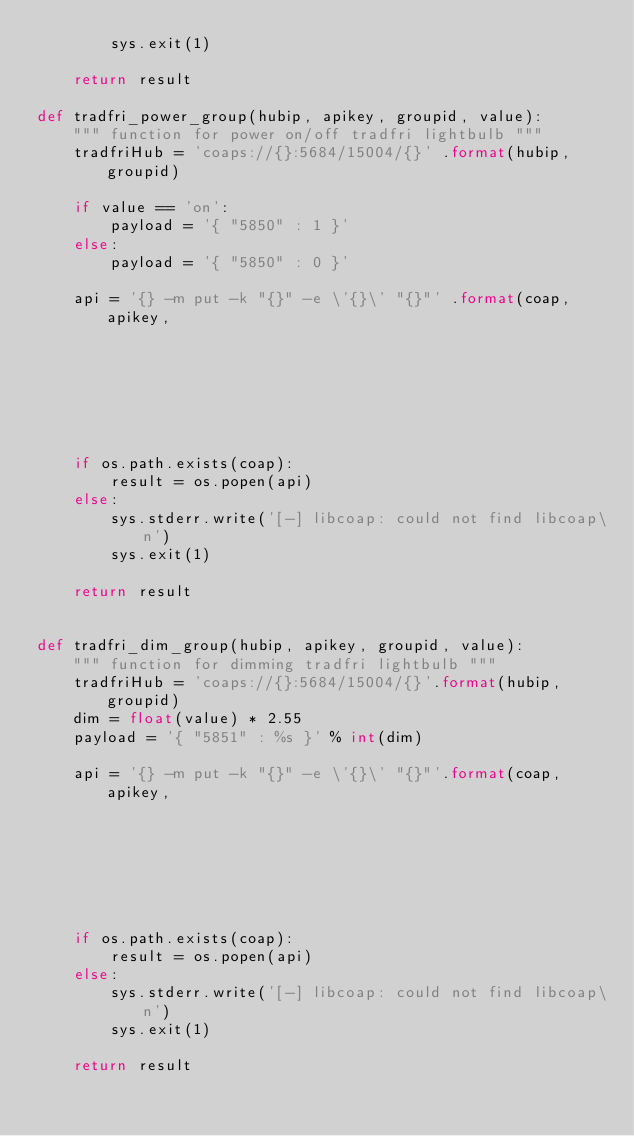Convert code to text. <code><loc_0><loc_0><loc_500><loc_500><_Python_>        sys.exit(1)

    return result

def tradfri_power_group(hubip, apikey, groupid, value):
    """ function for power on/off tradfri lightbulb """
    tradfriHub = 'coaps://{}:5684/15004/{}' .format(hubip, groupid)

    if value == 'on':
        payload = '{ "5850" : 1 }'
    else:
        payload = '{ "5850" : 0 }'

    api = '{} -m put -k "{}" -e \'{}\' "{}"' .format(coap, apikey,
                                                                          payload, tradfriHub)

    if os.path.exists(coap):
        result = os.popen(api)
    else:
        sys.stderr.write('[-] libcoap: could not find libcoap\n')
        sys.exit(1)

    return result


def tradfri_dim_group(hubip, apikey, groupid, value):
    """ function for dimming tradfri lightbulb """
    tradfriHub = 'coaps://{}:5684/15004/{}'.format(hubip, groupid)
    dim = float(value) * 2.55
    payload = '{ "5851" : %s }' % int(dim)

    api = '{} -m put -k "{}" -e \'{}\' "{}"'.format(coap, apikey,
                                                                         payload, tradfriHub)

    if os.path.exists(coap):
        result = os.popen(api)
    else:
        sys.stderr.write('[-] libcoap: could not find libcoap\n')
        sys.exit(1)

    return result
</code> 